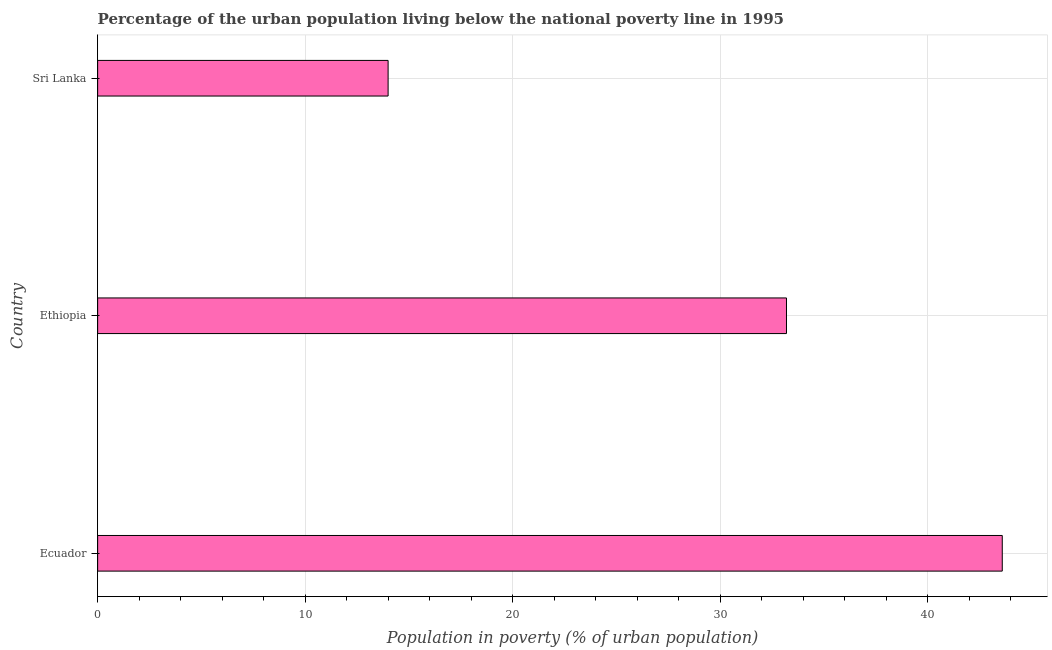Does the graph contain any zero values?
Ensure brevity in your answer.  No. What is the title of the graph?
Ensure brevity in your answer.  Percentage of the urban population living below the national poverty line in 1995. What is the label or title of the X-axis?
Keep it short and to the point. Population in poverty (% of urban population). What is the percentage of urban population living below poverty line in Ethiopia?
Your answer should be very brief. 33.2. Across all countries, what is the maximum percentage of urban population living below poverty line?
Offer a terse response. 43.6. Across all countries, what is the minimum percentage of urban population living below poverty line?
Provide a short and direct response. 14. In which country was the percentage of urban population living below poverty line maximum?
Keep it short and to the point. Ecuador. In which country was the percentage of urban population living below poverty line minimum?
Keep it short and to the point. Sri Lanka. What is the sum of the percentage of urban population living below poverty line?
Keep it short and to the point. 90.8. What is the average percentage of urban population living below poverty line per country?
Ensure brevity in your answer.  30.27. What is the median percentage of urban population living below poverty line?
Offer a very short reply. 33.2. In how many countries, is the percentage of urban population living below poverty line greater than 2 %?
Your answer should be compact. 3. What is the ratio of the percentage of urban population living below poverty line in Ethiopia to that in Sri Lanka?
Offer a terse response. 2.37. Is the percentage of urban population living below poverty line in Ecuador less than that in Ethiopia?
Offer a very short reply. No. Is the difference between the percentage of urban population living below poverty line in Ecuador and Sri Lanka greater than the difference between any two countries?
Make the answer very short. Yes. What is the difference between the highest and the second highest percentage of urban population living below poverty line?
Ensure brevity in your answer.  10.4. What is the difference between the highest and the lowest percentage of urban population living below poverty line?
Keep it short and to the point. 29.6. In how many countries, is the percentage of urban population living below poverty line greater than the average percentage of urban population living below poverty line taken over all countries?
Your answer should be very brief. 2. How many bars are there?
Provide a succinct answer. 3. Are all the bars in the graph horizontal?
Your answer should be compact. Yes. How many countries are there in the graph?
Provide a short and direct response. 3. What is the difference between two consecutive major ticks on the X-axis?
Your response must be concise. 10. Are the values on the major ticks of X-axis written in scientific E-notation?
Make the answer very short. No. What is the Population in poverty (% of urban population) in Ecuador?
Provide a short and direct response. 43.6. What is the Population in poverty (% of urban population) in Ethiopia?
Provide a short and direct response. 33.2. What is the Population in poverty (% of urban population) in Sri Lanka?
Keep it short and to the point. 14. What is the difference between the Population in poverty (% of urban population) in Ecuador and Ethiopia?
Your answer should be compact. 10.4. What is the difference between the Population in poverty (% of urban population) in Ecuador and Sri Lanka?
Make the answer very short. 29.6. What is the ratio of the Population in poverty (% of urban population) in Ecuador to that in Ethiopia?
Your answer should be compact. 1.31. What is the ratio of the Population in poverty (% of urban population) in Ecuador to that in Sri Lanka?
Your answer should be very brief. 3.11. What is the ratio of the Population in poverty (% of urban population) in Ethiopia to that in Sri Lanka?
Your response must be concise. 2.37. 